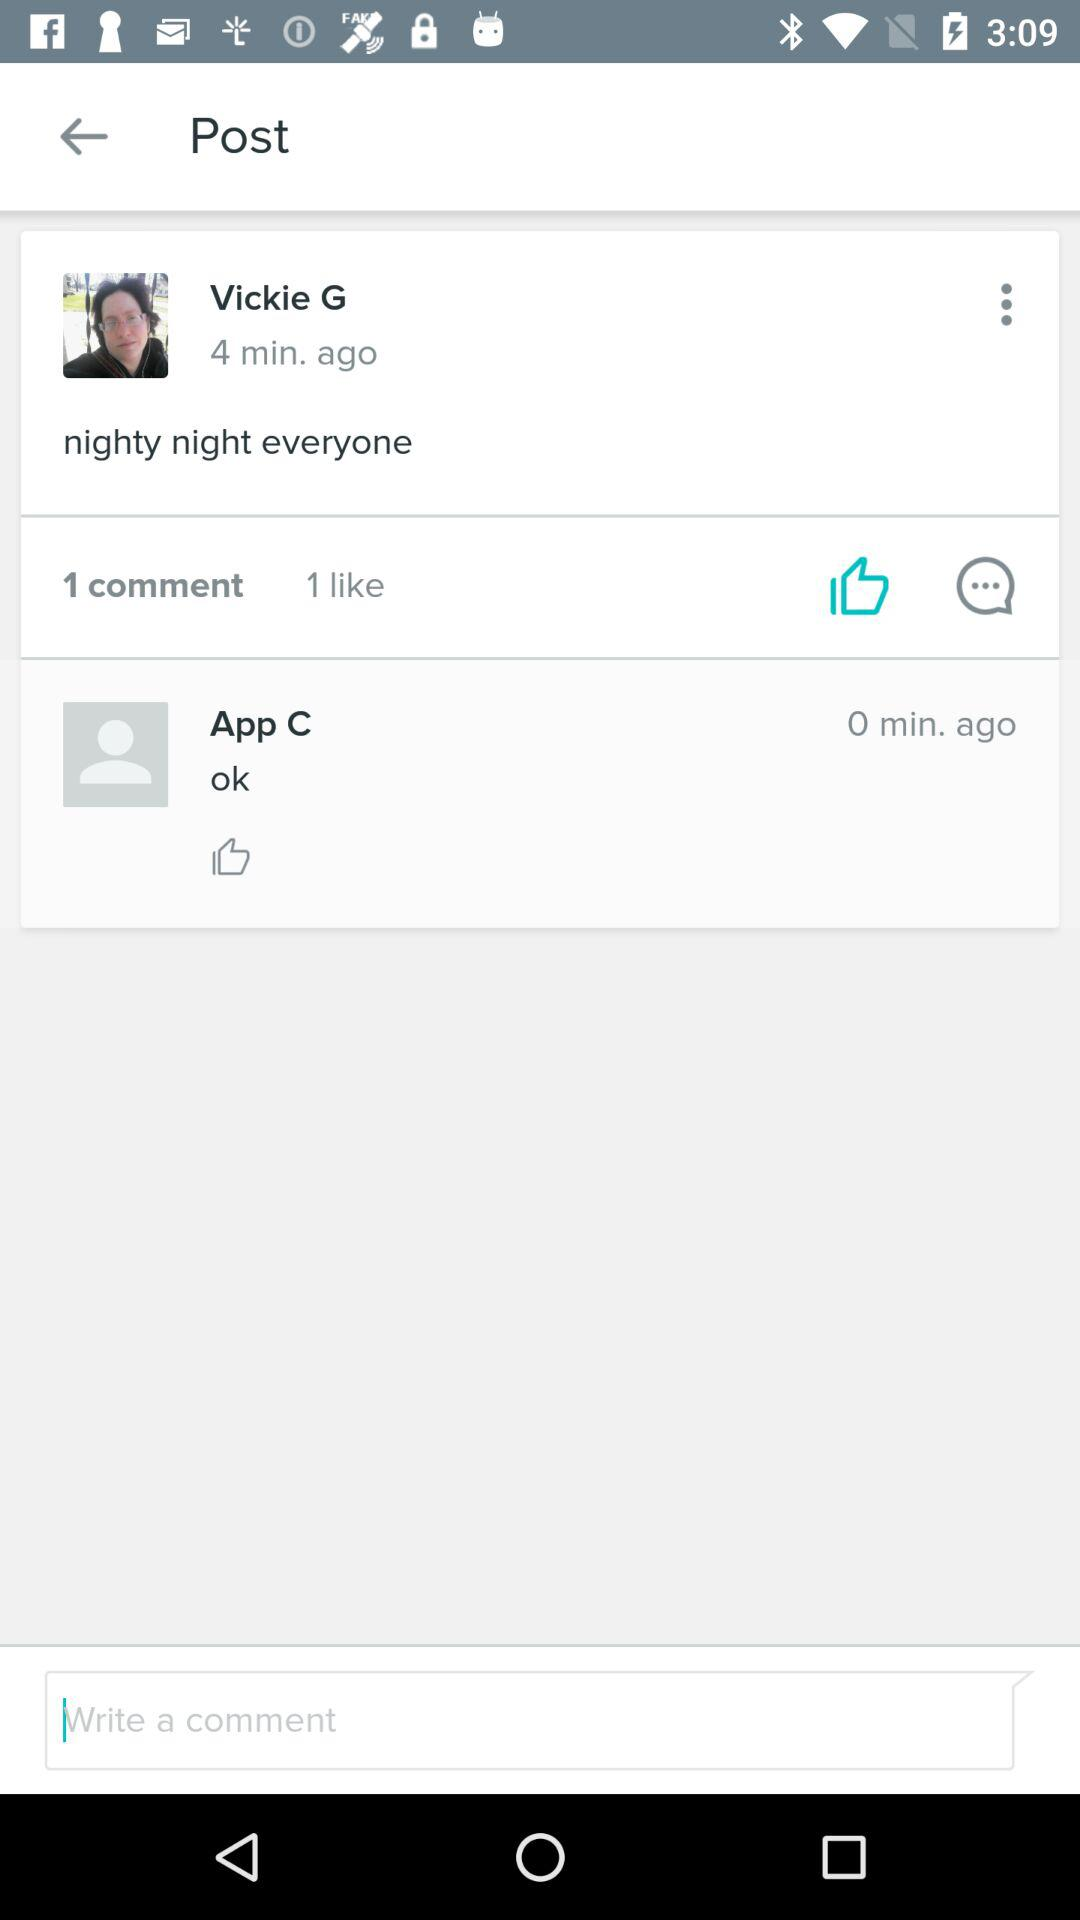How many of them liked the post? The post was liked by 1. 